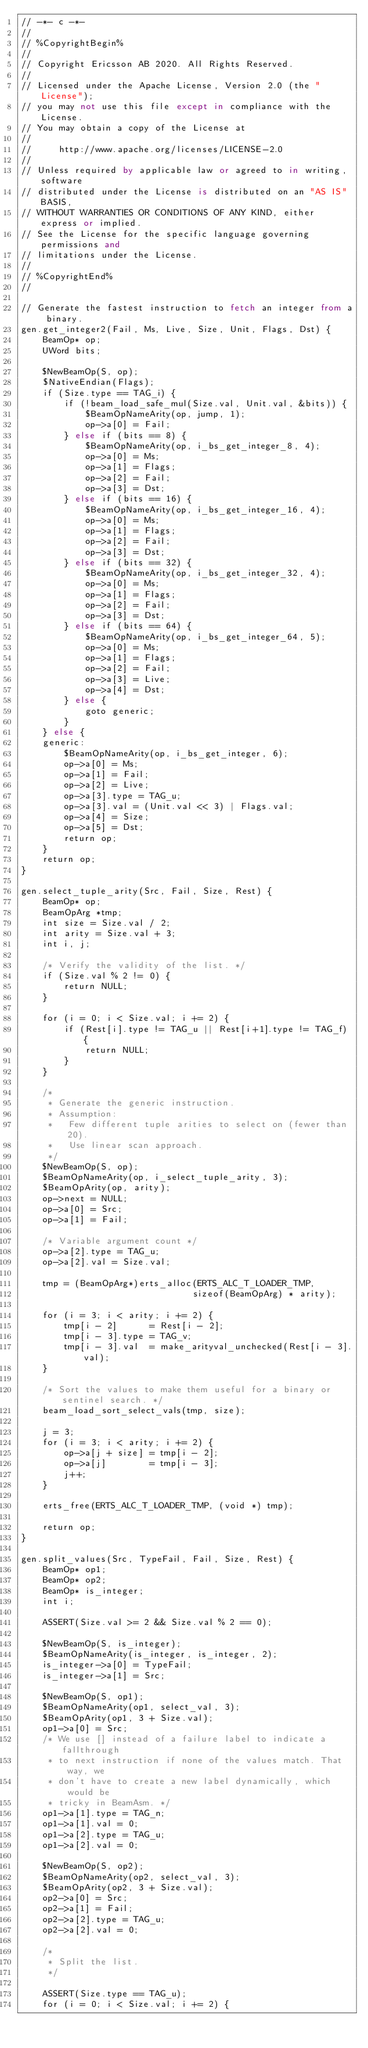Convert code to text. <code><loc_0><loc_0><loc_500><loc_500><_SQL_>// -*- c -*-
//
// %CopyrightBegin%
//
// Copyright Ericsson AB 2020. All Rights Reserved.
//
// Licensed under the Apache License, Version 2.0 (the "License");
// you may not use this file except in compliance with the License.
// You may obtain a copy of the License at
//
//     http://www.apache.org/licenses/LICENSE-2.0
//
// Unless required by applicable law or agreed to in writing, software
// distributed under the License is distributed on an "AS IS" BASIS,
// WITHOUT WARRANTIES OR CONDITIONS OF ANY KIND, either express or implied.
// See the License for the specific language governing permissions and
// limitations under the License.
//
// %CopyrightEnd%
//

// Generate the fastest instruction to fetch an integer from a binary.
gen.get_integer2(Fail, Ms, Live, Size, Unit, Flags, Dst) {
    BeamOp* op;
    UWord bits;

    $NewBeamOp(S, op);
    $NativeEndian(Flags);
    if (Size.type == TAG_i) {
        if (!beam_load_safe_mul(Size.val, Unit.val, &bits)) {
            $BeamOpNameArity(op, jump, 1);
            op->a[0] = Fail;
        } else if (bits == 8) {
            $BeamOpNameArity(op, i_bs_get_integer_8, 4);
            op->a[0] = Ms;
            op->a[1] = Flags;
            op->a[2] = Fail;
            op->a[3] = Dst;
        } else if (bits == 16) {
            $BeamOpNameArity(op, i_bs_get_integer_16, 4);
            op->a[0] = Ms;
            op->a[1] = Flags;
            op->a[2] = Fail;
            op->a[3] = Dst;
        } else if (bits == 32) {
            $BeamOpNameArity(op, i_bs_get_integer_32, 4);
            op->a[0] = Ms;
            op->a[1] = Flags;
            op->a[2] = Fail;
            op->a[3] = Dst;
        } else if (bits == 64) {
            $BeamOpNameArity(op, i_bs_get_integer_64, 5);
            op->a[0] = Ms;
            op->a[1] = Flags;
            op->a[2] = Fail;
            op->a[3] = Live;
            op->a[4] = Dst;
        } else {
            goto generic;
        }
    } else {
    generic:
        $BeamOpNameArity(op, i_bs_get_integer, 6);
        op->a[0] = Ms;
        op->a[1] = Fail;
        op->a[2] = Live;
        op->a[3].type = TAG_u;
        op->a[3].val = (Unit.val << 3) | Flags.val;
        op->a[4] = Size;
        op->a[5] = Dst;
        return op;
    }
    return op;
}

gen.select_tuple_arity(Src, Fail, Size, Rest) {
    BeamOp* op;
    BeamOpArg *tmp;
    int size = Size.val / 2;
    int arity = Size.val + 3;
    int i, j;

    /* Verify the validity of the list. */
    if (Size.val % 2 != 0) {
        return NULL;
    }

    for (i = 0; i < Size.val; i += 2) {
        if (Rest[i].type != TAG_u || Rest[i+1].type != TAG_f) {
            return NULL;
        }
    }

    /*
     * Generate the generic instruction.
     * Assumption:
     *   Few different tuple arities to select on (fewer than 20).
     *   Use linear scan approach.
     */
    $NewBeamOp(S, op);
    $BeamOpNameArity(op, i_select_tuple_arity, 3);
    $BeamOpArity(op, arity);
    op->next = NULL;
    op->a[0] = Src;
    op->a[1] = Fail;

    /* Variable argument count */
    op->a[2].type = TAG_u;
    op->a[2].val = Size.val;

    tmp = (BeamOpArg*)erts_alloc(ERTS_ALC_T_LOADER_TMP,
                                sizeof(BeamOpArg) * arity);

    for (i = 3; i < arity; i += 2) {
        tmp[i - 2]      = Rest[i - 2];
        tmp[i - 3].type = TAG_v;
        tmp[i - 3].val  = make_arityval_unchecked(Rest[i - 3].val);
    }

    /* Sort the values to make them useful for a binary or sentinel search. */
    beam_load_sort_select_vals(tmp, size);

    j = 3;
    for (i = 3; i < arity; i += 2) {
        op->a[j + size] = tmp[i - 2];
        op->a[j]        = tmp[i - 3];
        j++;
    }

    erts_free(ERTS_ALC_T_LOADER_TMP, (void *) tmp);

    return op;
}

gen.split_values(Src, TypeFail, Fail, Size, Rest) {
    BeamOp* op1;
    BeamOp* op2;
    BeamOp* is_integer;
    int i;

    ASSERT(Size.val >= 2 && Size.val % 2 == 0);

    $NewBeamOp(S, is_integer);
    $BeamOpNameArity(is_integer, is_integer, 2);
    is_integer->a[0] = TypeFail;
    is_integer->a[1] = Src;

    $NewBeamOp(S, op1);
    $BeamOpNameArity(op1, select_val, 3);
    $BeamOpArity(op1, 3 + Size.val);
    op1->a[0] = Src;
    /* We use [] instead of a failure label to indicate a fallthrough
     * to next instruction if none of the values match. That way, we
     * don't have to create a new label dynamically, which would be
     * tricky in BeamAsm. */
    op1->a[1].type = TAG_n;
    op1->a[1].val = 0;
    op1->a[2].type = TAG_u;
    op1->a[2].val = 0;

    $NewBeamOp(S, op2);
    $BeamOpNameArity(op2, select_val, 3);
    $BeamOpArity(op2, 3 + Size.val);
    op2->a[0] = Src;
    op2->a[1] = Fail;
    op2->a[2].type = TAG_u;
    op2->a[2].val = 0;

    /*
     * Split the list.
     */

    ASSERT(Size.type == TAG_u);
    for (i = 0; i < Size.val; i += 2) {</code> 